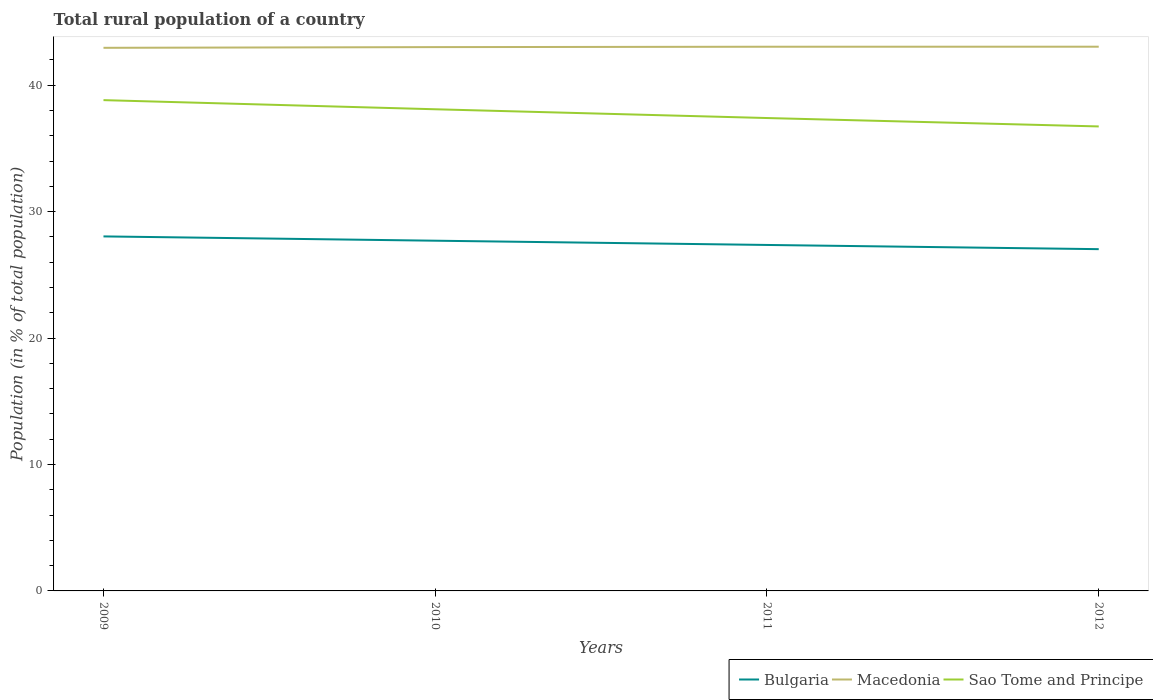How many different coloured lines are there?
Make the answer very short. 3. Across all years, what is the maximum rural population in Sao Tome and Principe?
Your answer should be very brief. 36.73. In which year was the rural population in Sao Tome and Principe maximum?
Your answer should be compact. 2012. What is the total rural population in Bulgaria in the graph?
Ensure brevity in your answer.  0.34. What is the difference between the highest and the second highest rural population in Macedonia?
Your answer should be very brief. 0.09. Is the rural population in Macedonia strictly greater than the rural population in Sao Tome and Principe over the years?
Your response must be concise. No. How many lines are there?
Your answer should be very brief. 3. How many years are there in the graph?
Offer a terse response. 4. What is the difference between two consecutive major ticks on the Y-axis?
Offer a terse response. 10. Are the values on the major ticks of Y-axis written in scientific E-notation?
Offer a terse response. No. Does the graph contain grids?
Your response must be concise. No. Where does the legend appear in the graph?
Make the answer very short. Bottom right. What is the title of the graph?
Provide a short and direct response. Total rural population of a country. What is the label or title of the X-axis?
Your response must be concise. Years. What is the label or title of the Y-axis?
Provide a succinct answer. Population (in % of total population). What is the Population (in % of total population) in Bulgaria in 2009?
Your answer should be compact. 28.04. What is the Population (in % of total population) of Macedonia in 2009?
Your response must be concise. 42.95. What is the Population (in % of total population) in Sao Tome and Principe in 2009?
Provide a short and direct response. 38.81. What is the Population (in % of total population) of Bulgaria in 2010?
Your answer should be compact. 27.7. What is the Population (in % of total population) in Macedonia in 2010?
Give a very brief answer. 43.01. What is the Population (in % of total population) of Sao Tome and Principe in 2010?
Ensure brevity in your answer.  38.09. What is the Population (in % of total population) in Bulgaria in 2011?
Give a very brief answer. 27.36. What is the Population (in % of total population) of Macedonia in 2011?
Offer a very short reply. 43.04. What is the Population (in % of total population) in Sao Tome and Principe in 2011?
Offer a very short reply. 37.4. What is the Population (in % of total population) of Bulgaria in 2012?
Offer a terse response. 27.03. What is the Population (in % of total population) of Macedonia in 2012?
Your answer should be very brief. 43.04. What is the Population (in % of total population) of Sao Tome and Principe in 2012?
Provide a succinct answer. 36.73. Across all years, what is the maximum Population (in % of total population) of Bulgaria?
Make the answer very short. 28.04. Across all years, what is the maximum Population (in % of total population) of Macedonia?
Your response must be concise. 43.04. Across all years, what is the maximum Population (in % of total population) in Sao Tome and Principe?
Your answer should be compact. 38.81. Across all years, what is the minimum Population (in % of total population) in Bulgaria?
Keep it short and to the point. 27.03. Across all years, what is the minimum Population (in % of total population) in Macedonia?
Your answer should be compact. 42.95. Across all years, what is the minimum Population (in % of total population) in Sao Tome and Principe?
Offer a terse response. 36.73. What is the total Population (in % of total population) in Bulgaria in the graph?
Offer a very short reply. 110.13. What is the total Population (in % of total population) in Macedonia in the graph?
Provide a succinct answer. 172.04. What is the total Population (in % of total population) in Sao Tome and Principe in the graph?
Keep it short and to the point. 151.04. What is the difference between the Population (in % of total population) in Bulgaria in 2009 and that in 2010?
Your response must be concise. 0.34. What is the difference between the Population (in % of total population) of Macedonia in 2009 and that in 2010?
Keep it short and to the point. -0.06. What is the difference between the Population (in % of total population) of Sao Tome and Principe in 2009 and that in 2010?
Your answer should be compact. 0.72. What is the difference between the Population (in % of total population) of Bulgaria in 2009 and that in 2011?
Your answer should be very brief. 0.68. What is the difference between the Population (in % of total population) in Macedonia in 2009 and that in 2011?
Your answer should be very brief. -0.09. What is the difference between the Population (in % of total population) of Sao Tome and Principe in 2009 and that in 2011?
Keep it short and to the point. 1.42. What is the difference between the Population (in % of total population) in Macedonia in 2009 and that in 2012?
Your response must be concise. -0.09. What is the difference between the Population (in % of total population) in Sao Tome and Principe in 2009 and that in 2012?
Offer a very short reply. 2.08. What is the difference between the Population (in % of total population) in Bulgaria in 2010 and that in 2011?
Your answer should be compact. 0.34. What is the difference between the Population (in % of total population) of Macedonia in 2010 and that in 2011?
Provide a short and direct response. -0.03. What is the difference between the Population (in % of total population) of Sao Tome and Principe in 2010 and that in 2011?
Ensure brevity in your answer.  0.69. What is the difference between the Population (in % of total population) in Bulgaria in 2010 and that in 2012?
Offer a very short reply. 0.67. What is the difference between the Population (in % of total population) in Macedonia in 2010 and that in 2012?
Give a very brief answer. -0.03. What is the difference between the Population (in % of total population) of Sao Tome and Principe in 2010 and that in 2012?
Provide a succinct answer. 1.36. What is the difference between the Population (in % of total population) of Bulgaria in 2011 and that in 2012?
Provide a short and direct response. 0.33. What is the difference between the Population (in % of total population) in Macedonia in 2011 and that in 2012?
Keep it short and to the point. -0. What is the difference between the Population (in % of total population) in Sao Tome and Principe in 2011 and that in 2012?
Your answer should be compact. 0.67. What is the difference between the Population (in % of total population) in Bulgaria in 2009 and the Population (in % of total population) in Macedonia in 2010?
Your response must be concise. -14.97. What is the difference between the Population (in % of total population) in Bulgaria in 2009 and the Population (in % of total population) in Sao Tome and Principe in 2010?
Provide a succinct answer. -10.06. What is the difference between the Population (in % of total population) of Macedonia in 2009 and the Population (in % of total population) of Sao Tome and Principe in 2010?
Ensure brevity in your answer.  4.86. What is the difference between the Population (in % of total population) in Bulgaria in 2009 and the Population (in % of total population) in Macedonia in 2011?
Provide a succinct answer. -15. What is the difference between the Population (in % of total population) of Bulgaria in 2009 and the Population (in % of total population) of Sao Tome and Principe in 2011?
Keep it short and to the point. -9.36. What is the difference between the Population (in % of total population) of Macedonia in 2009 and the Population (in % of total population) of Sao Tome and Principe in 2011?
Your response must be concise. 5.55. What is the difference between the Population (in % of total population) in Bulgaria in 2009 and the Population (in % of total population) in Macedonia in 2012?
Ensure brevity in your answer.  -15. What is the difference between the Population (in % of total population) of Bulgaria in 2009 and the Population (in % of total population) of Sao Tome and Principe in 2012?
Your answer should be very brief. -8.7. What is the difference between the Population (in % of total population) in Macedonia in 2009 and the Population (in % of total population) in Sao Tome and Principe in 2012?
Your answer should be compact. 6.22. What is the difference between the Population (in % of total population) in Bulgaria in 2010 and the Population (in % of total population) in Macedonia in 2011?
Your answer should be very brief. -15.34. What is the difference between the Population (in % of total population) of Bulgaria in 2010 and the Population (in % of total population) of Sao Tome and Principe in 2011?
Your response must be concise. -9.7. What is the difference between the Population (in % of total population) in Macedonia in 2010 and the Population (in % of total population) in Sao Tome and Principe in 2011?
Your answer should be very brief. 5.61. What is the difference between the Population (in % of total population) of Bulgaria in 2010 and the Population (in % of total population) of Macedonia in 2012?
Your answer should be very brief. -15.34. What is the difference between the Population (in % of total population) in Bulgaria in 2010 and the Population (in % of total population) in Sao Tome and Principe in 2012?
Your response must be concise. -9.04. What is the difference between the Population (in % of total population) in Macedonia in 2010 and the Population (in % of total population) in Sao Tome and Principe in 2012?
Your answer should be very brief. 6.27. What is the difference between the Population (in % of total population) of Bulgaria in 2011 and the Population (in % of total population) of Macedonia in 2012?
Your response must be concise. -15.68. What is the difference between the Population (in % of total population) in Bulgaria in 2011 and the Population (in % of total population) in Sao Tome and Principe in 2012?
Offer a very short reply. -9.37. What is the difference between the Population (in % of total population) of Macedonia in 2011 and the Population (in % of total population) of Sao Tome and Principe in 2012?
Offer a terse response. 6.3. What is the average Population (in % of total population) in Bulgaria per year?
Your answer should be very brief. 27.53. What is the average Population (in % of total population) of Macedonia per year?
Offer a very short reply. 43.01. What is the average Population (in % of total population) in Sao Tome and Principe per year?
Give a very brief answer. 37.76. In the year 2009, what is the difference between the Population (in % of total population) of Bulgaria and Population (in % of total population) of Macedonia?
Give a very brief answer. -14.92. In the year 2009, what is the difference between the Population (in % of total population) of Bulgaria and Population (in % of total population) of Sao Tome and Principe?
Keep it short and to the point. -10.78. In the year 2009, what is the difference between the Population (in % of total population) of Macedonia and Population (in % of total population) of Sao Tome and Principe?
Keep it short and to the point. 4.14. In the year 2010, what is the difference between the Population (in % of total population) in Bulgaria and Population (in % of total population) in Macedonia?
Offer a very short reply. -15.31. In the year 2010, what is the difference between the Population (in % of total population) in Bulgaria and Population (in % of total population) in Sao Tome and Principe?
Offer a very short reply. -10.39. In the year 2010, what is the difference between the Population (in % of total population) in Macedonia and Population (in % of total population) in Sao Tome and Principe?
Offer a terse response. 4.92. In the year 2011, what is the difference between the Population (in % of total population) in Bulgaria and Population (in % of total population) in Macedonia?
Make the answer very short. -15.68. In the year 2011, what is the difference between the Population (in % of total population) in Bulgaria and Population (in % of total population) in Sao Tome and Principe?
Ensure brevity in your answer.  -10.04. In the year 2011, what is the difference between the Population (in % of total population) of Macedonia and Population (in % of total population) of Sao Tome and Principe?
Make the answer very short. 5.64. In the year 2012, what is the difference between the Population (in % of total population) of Bulgaria and Population (in % of total population) of Macedonia?
Offer a terse response. -16.01. In the year 2012, what is the difference between the Population (in % of total population) in Bulgaria and Population (in % of total population) in Sao Tome and Principe?
Offer a terse response. -9.71. In the year 2012, what is the difference between the Population (in % of total population) in Macedonia and Population (in % of total population) in Sao Tome and Principe?
Offer a very short reply. 6.31. What is the ratio of the Population (in % of total population) of Bulgaria in 2009 to that in 2010?
Provide a succinct answer. 1.01. What is the ratio of the Population (in % of total population) of Bulgaria in 2009 to that in 2011?
Give a very brief answer. 1.02. What is the ratio of the Population (in % of total population) of Macedonia in 2009 to that in 2011?
Ensure brevity in your answer.  1. What is the ratio of the Population (in % of total population) of Sao Tome and Principe in 2009 to that in 2011?
Make the answer very short. 1.04. What is the ratio of the Population (in % of total population) of Bulgaria in 2009 to that in 2012?
Your answer should be compact. 1.04. What is the ratio of the Population (in % of total population) in Sao Tome and Principe in 2009 to that in 2012?
Offer a very short reply. 1.06. What is the ratio of the Population (in % of total population) of Bulgaria in 2010 to that in 2011?
Ensure brevity in your answer.  1.01. What is the ratio of the Population (in % of total population) of Sao Tome and Principe in 2010 to that in 2011?
Offer a terse response. 1.02. What is the ratio of the Population (in % of total population) in Bulgaria in 2010 to that in 2012?
Provide a short and direct response. 1.02. What is the ratio of the Population (in % of total population) of Sao Tome and Principe in 2010 to that in 2012?
Your answer should be very brief. 1.04. What is the ratio of the Population (in % of total population) in Bulgaria in 2011 to that in 2012?
Your response must be concise. 1.01. What is the ratio of the Population (in % of total population) of Macedonia in 2011 to that in 2012?
Make the answer very short. 1. What is the ratio of the Population (in % of total population) of Sao Tome and Principe in 2011 to that in 2012?
Keep it short and to the point. 1.02. What is the difference between the highest and the second highest Population (in % of total population) of Bulgaria?
Provide a succinct answer. 0.34. What is the difference between the highest and the second highest Population (in % of total population) of Macedonia?
Give a very brief answer. 0. What is the difference between the highest and the second highest Population (in % of total population) in Sao Tome and Principe?
Give a very brief answer. 0.72. What is the difference between the highest and the lowest Population (in % of total population) of Bulgaria?
Your response must be concise. 1.01. What is the difference between the highest and the lowest Population (in % of total population) in Macedonia?
Your answer should be very brief. 0.09. What is the difference between the highest and the lowest Population (in % of total population) of Sao Tome and Principe?
Make the answer very short. 2.08. 